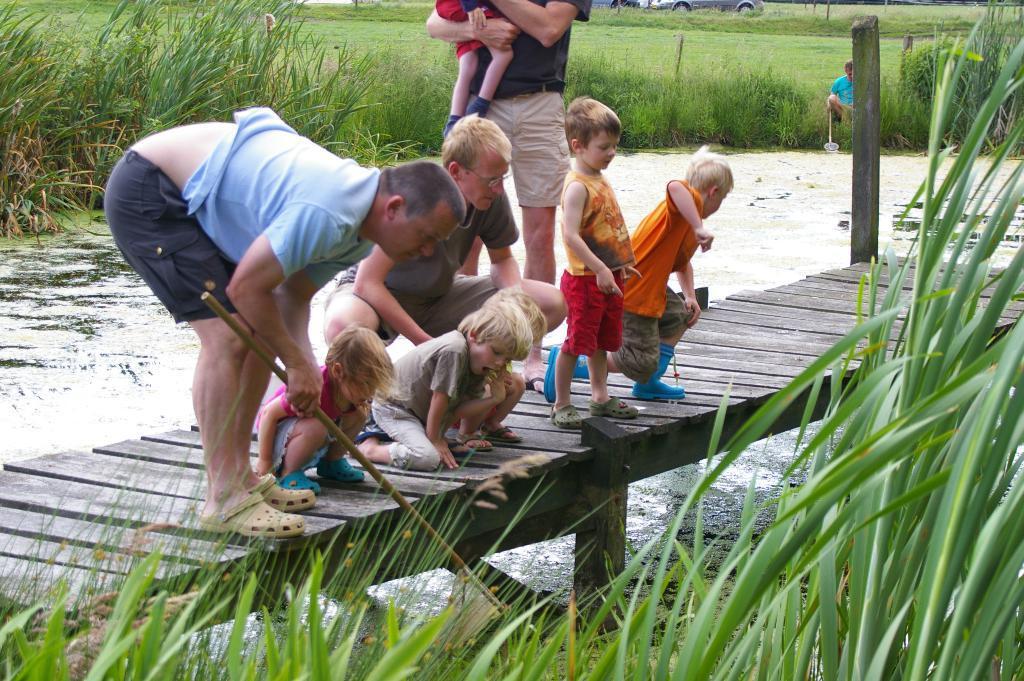How would you summarize this image in a sentence or two? In this image we can see a group of people and some children on the deck which is on the water. In that a man is holding a stick and the other is carrying a child. We can also see some plants, grass, a wooden pole, a person sitting holding a stick and a car. 